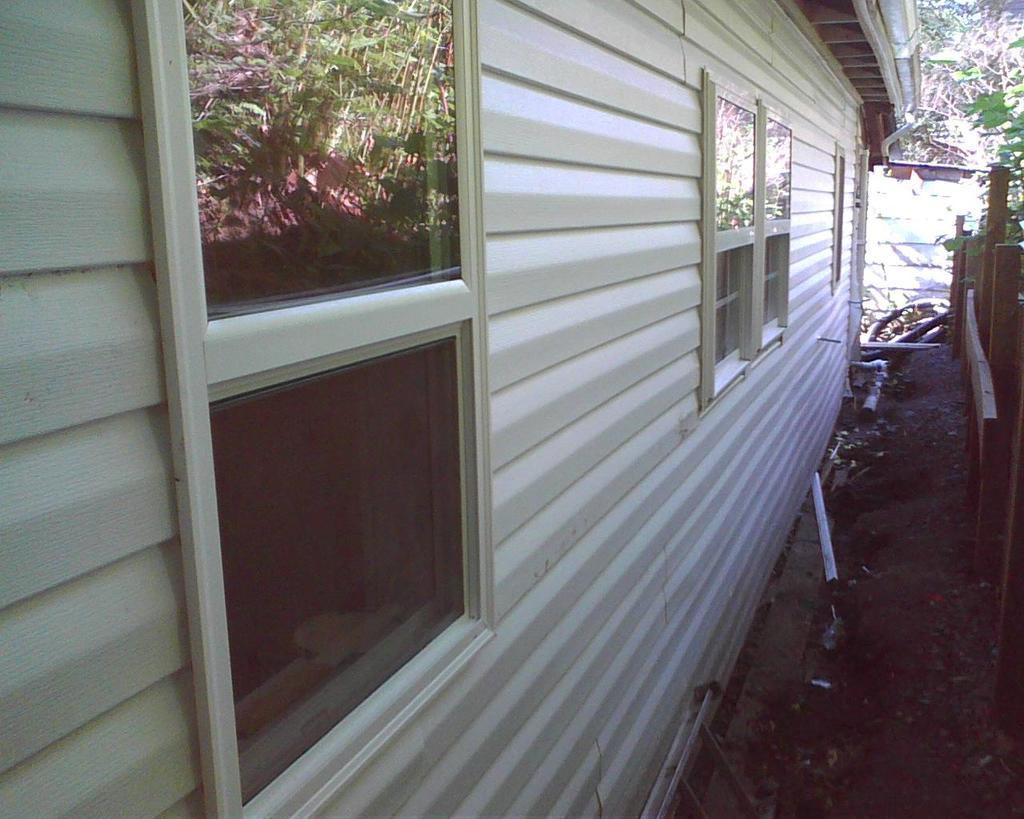What type of structure is visible in the image? There is a building in the image. What feature can be seen on the building? The building has windows. What is located on the right side of the image? There is wooden fencing on the right side of the image. What can be seen reflected on the windows? There is a reflection of plants on the window. How many bags can be seen hanging from the wooden fencing in the image? There are no bags visible in the image; it only features a building, windows, and wooden fencing. 